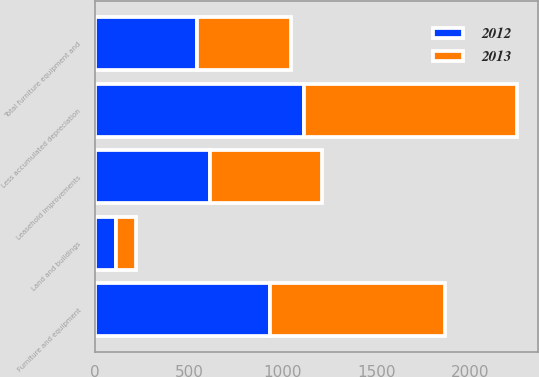<chart> <loc_0><loc_0><loc_500><loc_500><stacked_bar_chart><ecel><fcel>Furniture and equipment<fcel>Leasehold improvements<fcel>Land and buildings<fcel>Less accumulated depreciation<fcel>Total furniture equipment and<nl><fcel>2012<fcel>930.7<fcel>611.4<fcel>109.6<fcel>1111.7<fcel>540<nl><fcel>2013<fcel>932.6<fcel>597.2<fcel>109.9<fcel>1134.9<fcel>504.8<nl></chart> 